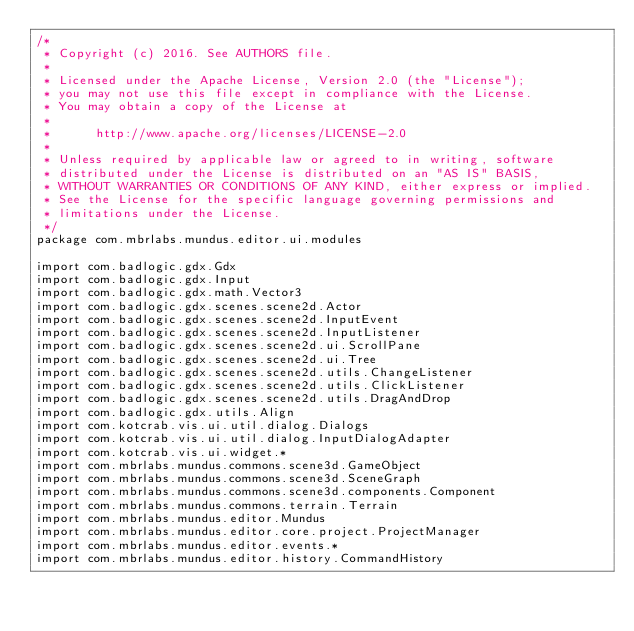<code> <loc_0><loc_0><loc_500><loc_500><_Kotlin_>/*
 * Copyright (c) 2016. See AUTHORS file.
 *
 * Licensed under the Apache License, Version 2.0 (the "License");
 * you may not use this file except in compliance with the License.
 * You may obtain a copy of the License at
 *
 *      http://www.apache.org/licenses/LICENSE-2.0
 *
 * Unless required by applicable law or agreed to in writing, software
 * distributed under the License is distributed on an "AS IS" BASIS,
 * WITHOUT WARRANTIES OR CONDITIONS OF ANY KIND, either express or implied.
 * See the License for the specific language governing permissions and
 * limitations under the License.
 */
package com.mbrlabs.mundus.editor.ui.modules

import com.badlogic.gdx.Gdx
import com.badlogic.gdx.Input
import com.badlogic.gdx.math.Vector3
import com.badlogic.gdx.scenes.scene2d.Actor
import com.badlogic.gdx.scenes.scene2d.InputEvent
import com.badlogic.gdx.scenes.scene2d.InputListener
import com.badlogic.gdx.scenes.scene2d.ui.ScrollPane
import com.badlogic.gdx.scenes.scene2d.ui.Tree
import com.badlogic.gdx.scenes.scene2d.utils.ChangeListener
import com.badlogic.gdx.scenes.scene2d.utils.ClickListener
import com.badlogic.gdx.scenes.scene2d.utils.DragAndDrop
import com.badlogic.gdx.utils.Align
import com.kotcrab.vis.ui.util.dialog.Dialogs
import com.kotcrab.vis.ui.util.dialog.InputDialogAdapter
import com.kotcrab.vis.ui.widget.*
import com.mbrlabs.mundus.commons.scene3d.GameObject
import com.mbrlabs.mundus.commons.scene3d.SceneGraph
import com.mbrlabs.mundus.commons.scene3d.components.Component
import com.mbrlabs.mundus.commons.terrain.Terrain
import com.mbrlabs.mundus.editor.Mundus
import com.mbrlabs.mundus.editor.core.project.ProjectManager
import com.mbrlabs.mundus.editor.events.*
import com.mbrlabs.mundus.editor.history.CommandHistory</code> 